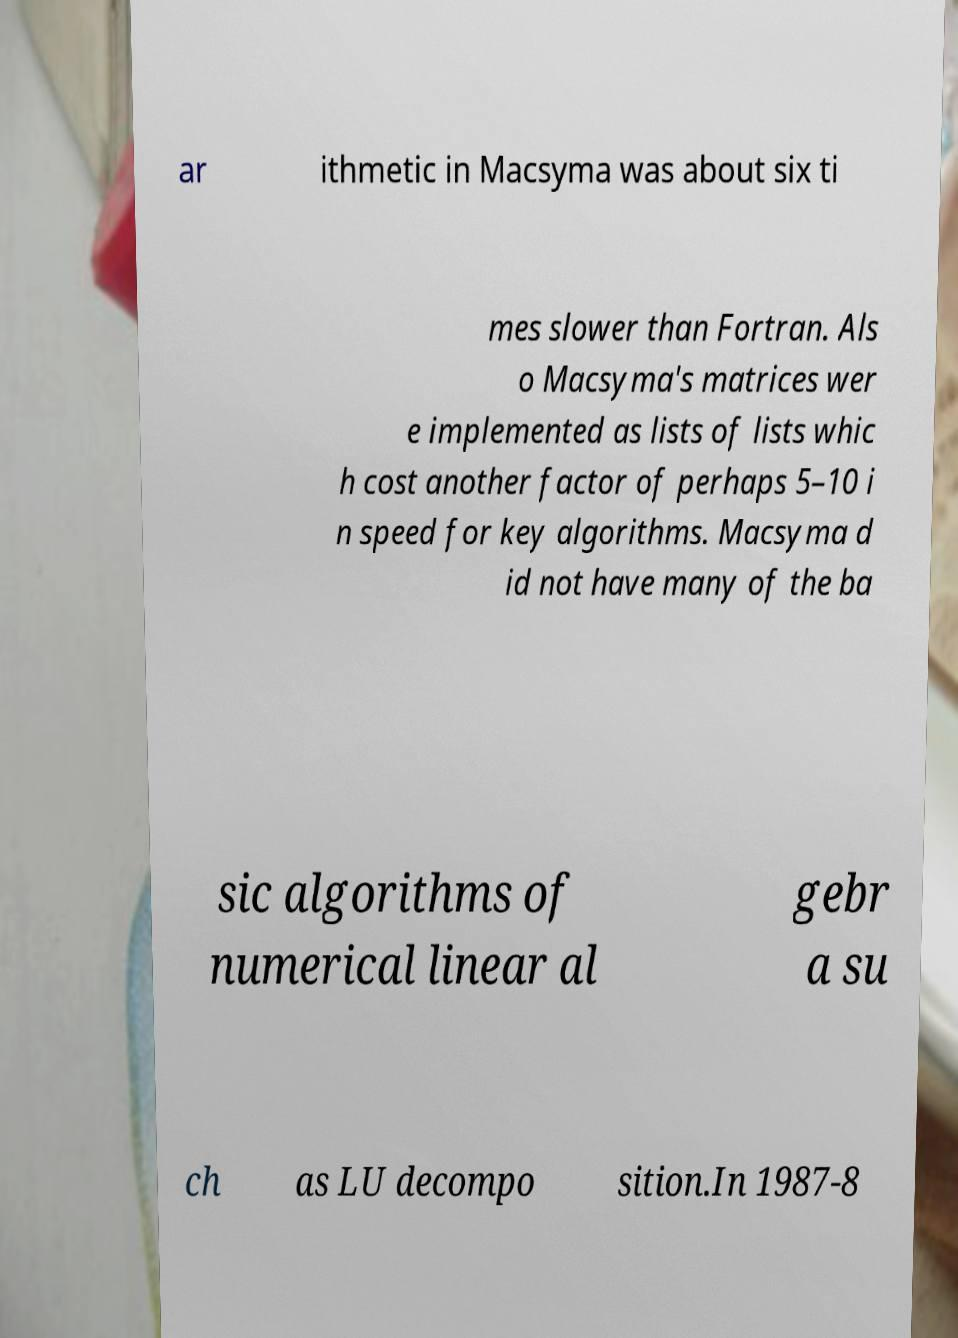Could you extract and type out the text from this image? ar ithmetic in Macsyma was about six ti mes slower than Fortran. Als o Macsyma's matrices wer e implemented as lists of lists whic h cost another factor of perhaps 5–10 i n speed for key algorithms. Macsyma d id not have many of the ba sic algorithms of numerical linear al gebr a su ch as LU decompo sition.In 1987-8 